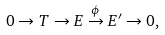Convert formula to latex. <formula><loc_0><loc_0><loc_500><loc_500>0 \to T \to E \overset { \phi } { \to } E ^ { \prime } \to 0 ,</formula> 